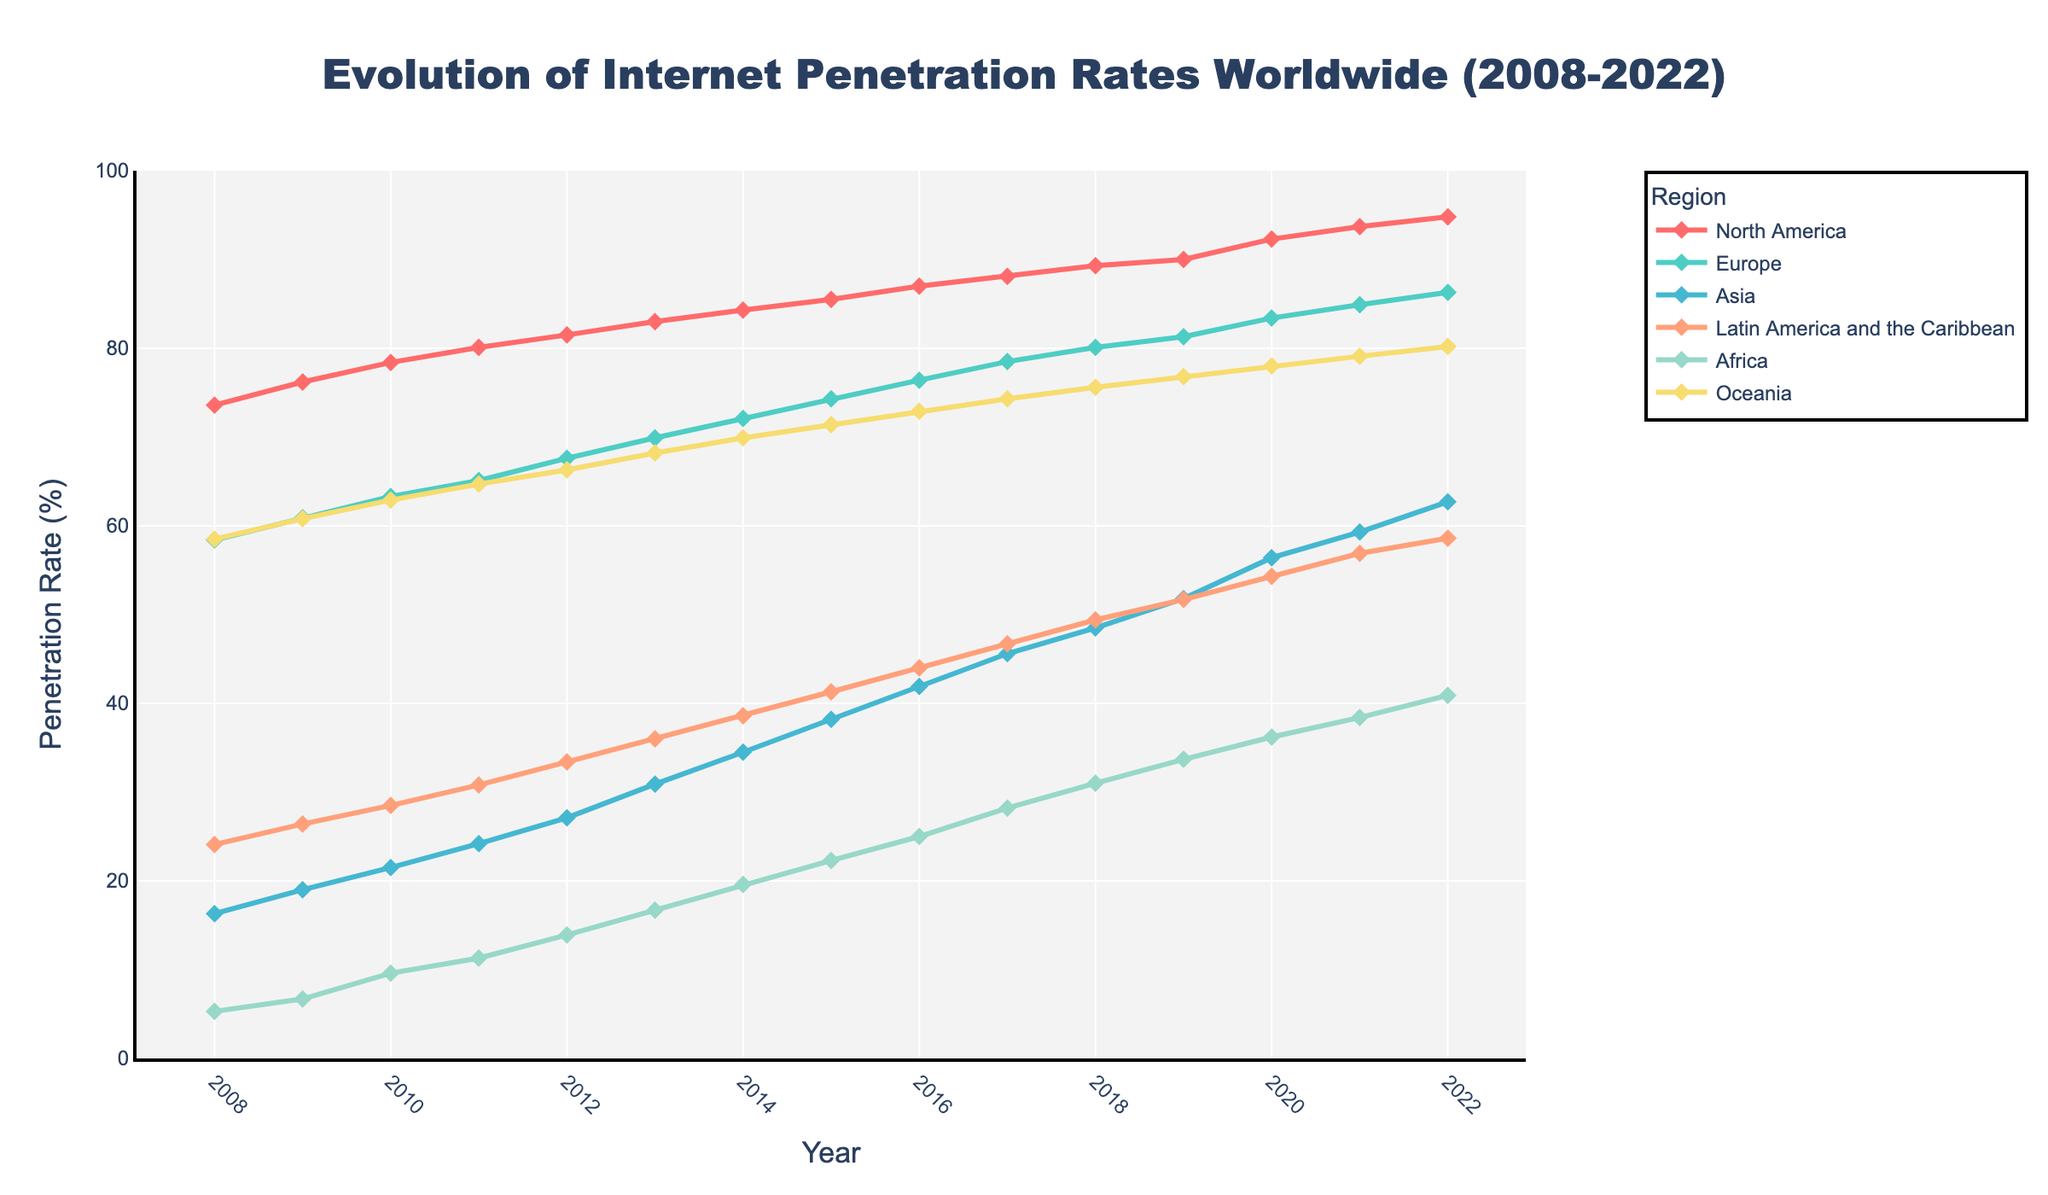What is the title of the figure? The title of the figure can be found at the top, usually in bold or larger font size. It states what the entire figure is about.
Answer: Evolution of Internet Penetration Rates Worldwide (2008-2022) What is the internet penetration rate in Europe in 2010? Look at the data point on the Europe line for the year 2010. These are usually marked by a line and marker on the graph.
Answer: 63.3% Which region had the highest internet penetration rate in 2022? Compare the data points for all regions in 2022. The region with the highest value on the y-axis will have the highest penetration rate.
Answer: North America How did the internet penetration rate in Africa change from 2008 to 2022? Examine the data points for Africa in both 2008 and 2022. Calculate the difference by subtracting the 2008 value from the 2022 value.
Answer: Increased by 35.6% In which year did North America first surpass a 90% internet penetration rate? Check the data points for North America across the years and identify the first year where the value is above 90%.
Answer: 2019 What is the overall trend of internet penetration in Asia from 2008 to 2022? Observe the data points for Asia over the entire time range. Determine whether the values are generally increasing, decreasing, or fluctuating.
Answer: Increasing Which region showed the most significant growth in internet penetration from 2008 to 2022? Compare the differences between the 2008 and 2022 values for all regions and determine which has the largest increase.
Answer: Africa Is there any year where the internet penetration rate in Oceania is higher than in Europe? Compare the year-wise data points between Europe and Oceania to find if there's any year where Oceania's data point is above that of Europe.
Answer: No How does the internet penetration rate in Latin America and the Caribbean in 2015 compare to that in Asia in the same year? Look at the values for Latin America and Asia for the year 2015 within the graph, and directly compare the numbers.
Answer: Latin America and the Caribbean are lower than Asia in 2015 What is the average internet penetration growth per year in North America from 2008 to 2022? Calculate the total growth by subtracting the 2008 value from the 2022 value. Divide this difference by the number of years (2022-2008).
Answer: (94.8% - 73.6%) / 14 = 1.51% per year 